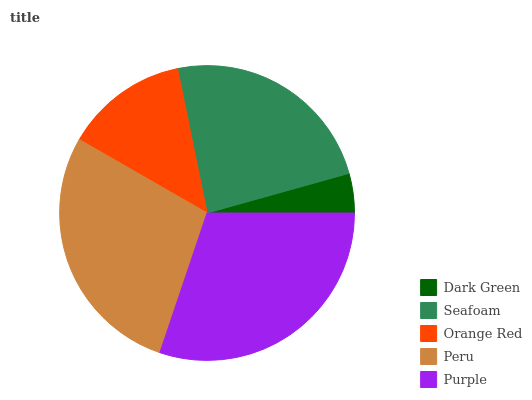Is Dark Green the minimum?
Answer yes or no. Yes. Is Purple the maximum?
Answer yes or no. Yes. Is Seafoam the minimum?
Answer yes or no. No. Is Seafoam the maximum?
Answer yes or no. No. Is Seafoam greater than Dark Green?
Answer yes or no. Yes. Is Dark Green less than Seafoam?
Answer yes or no. Yes. Is Dark Green greater than Seafoam?
Answer yes or no. No. Is Seafoam less than Dark Green?
Answer yes or no. No. Is Seafoam the high median?
Answer yes or no. Yes. Is Seafoam the low median?
Answer yes or no. Yes. Is Orange Red the high median?
Answer yes or no. No. Is Purple the low median?
Answer yes or no. No. 